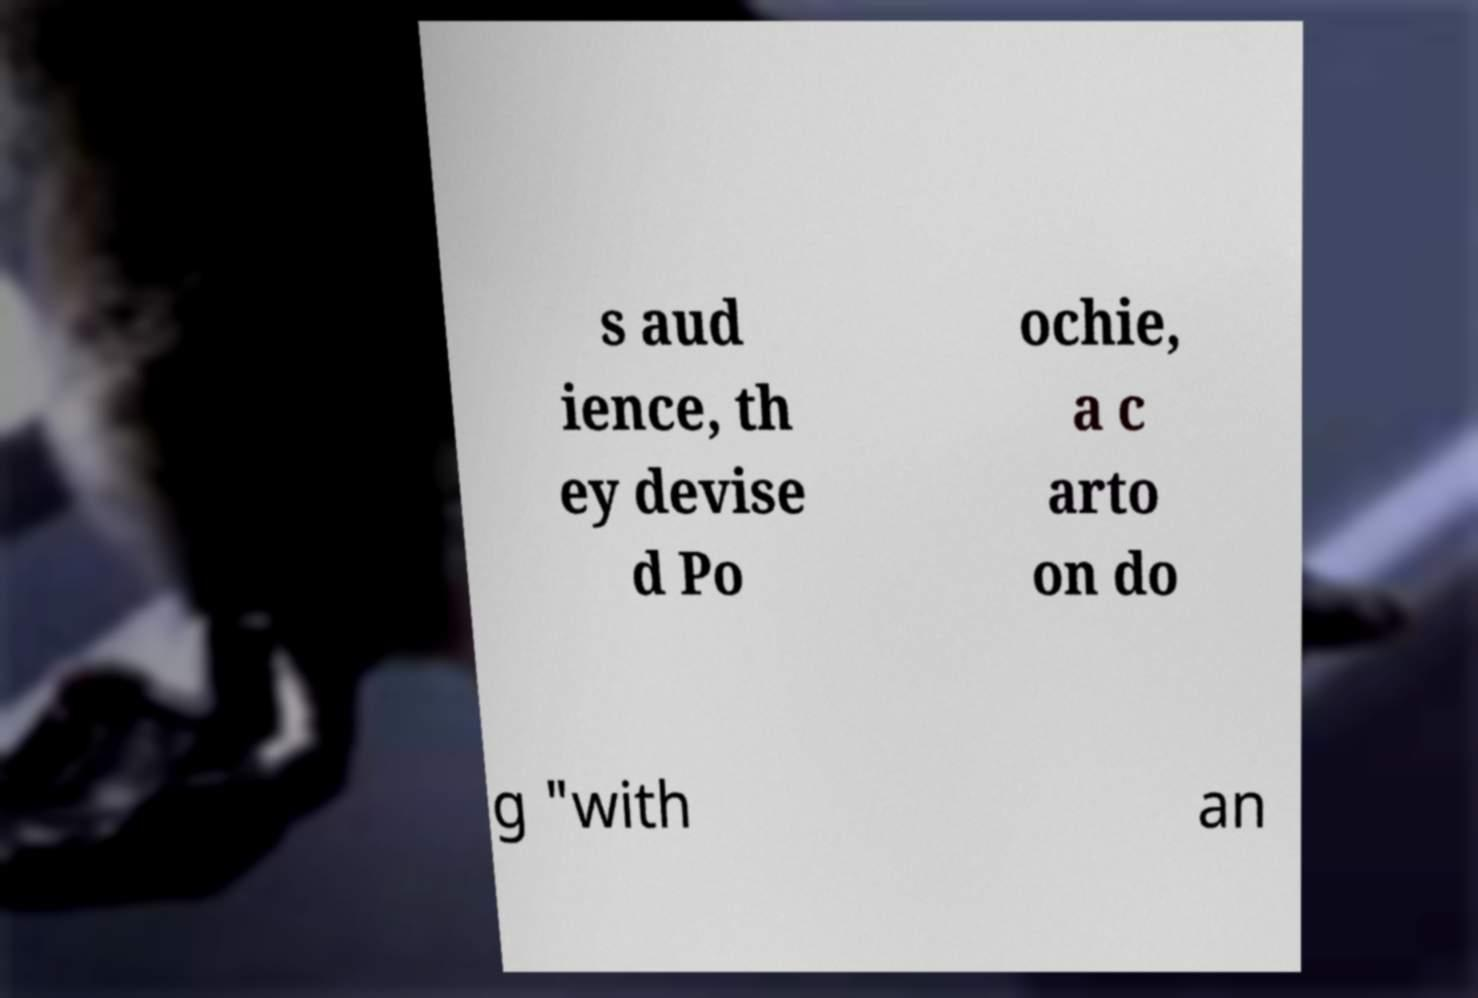Could you assist in decoding the text presented in this image and type it out clearly? s aud ience, th ey devise d Po ochie, a c arto on do g "with an 